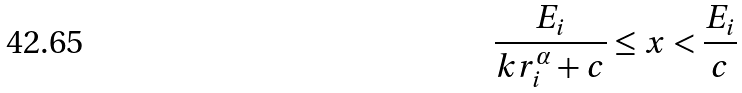Convert formula to latex. <formula><loc_0><loc_0><loc_500><loc_500>\frac { E _ { i } } { k r _ { i } ^ { \alpha } + c } \leq x < \frac { E _ { i } } { c }</formula> 